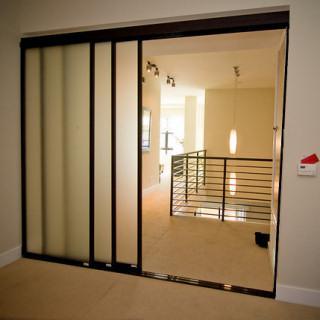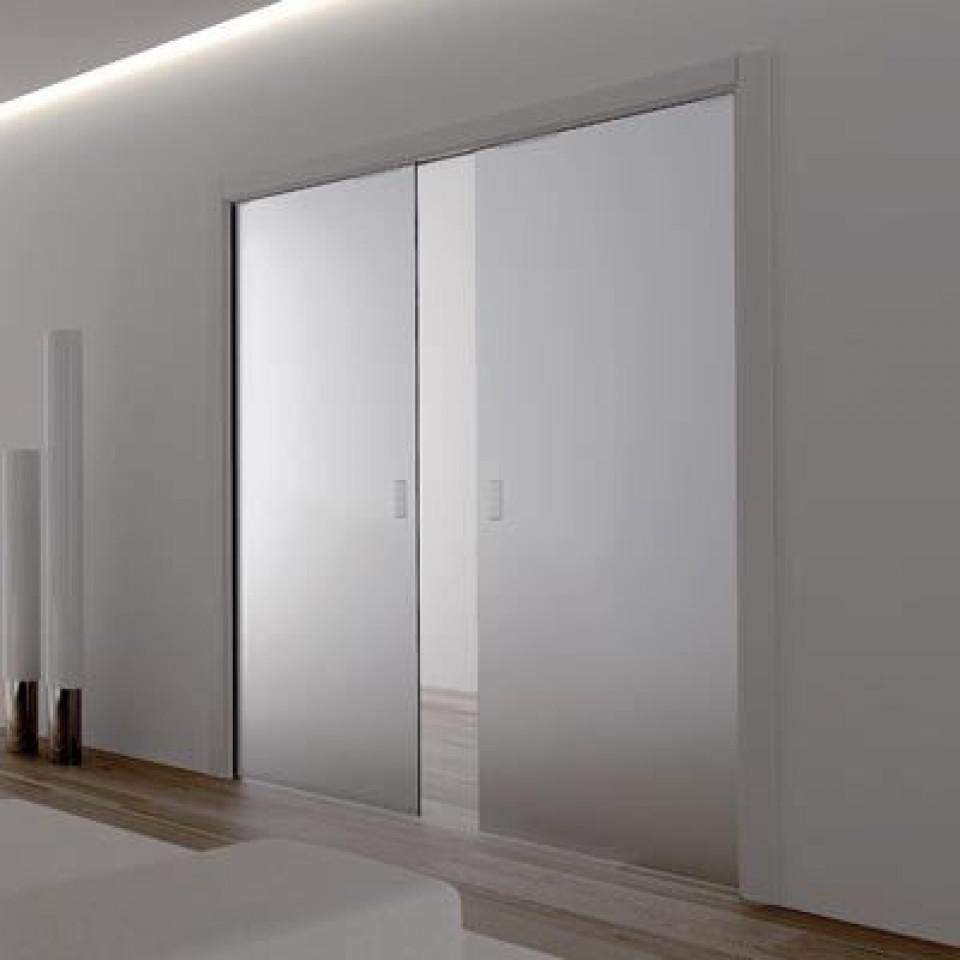The first image is the image on the left, the second image is the image on the right. For the images displayed, is the sentence "One set of sliding doors is white." factually correct? Answer yes or no. No. 